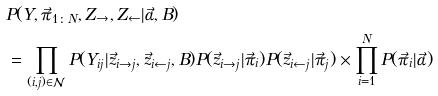<formula> <loc_0><loc_0><loc_500><loc_500>& P ( Y , \vec { \pi } _ { 1 \colon N } , Z _ { \rightarrow } , Z _ { \leftarrow } | \vec { \alpha } , B ) \\ & = \prod _ { ( i , j ) \in \mathcal { N } } P ( Y _ { i j } | \vec { z } _ { i \rightarrow j } , \vec { z } _ { i \leftarrow j } , B ) P ( \vec { z } _ { i \rightarrow j } | \vec { \pi } _ { i } ) P ( \vec { z } _ { i \leftarrow j } | \vec { \pi } _ { j } ) \times \prod _ { i = 1 } ^ { N } P ( \vec { \pi } _ { i } | \vec { \alpha } )</formula> 